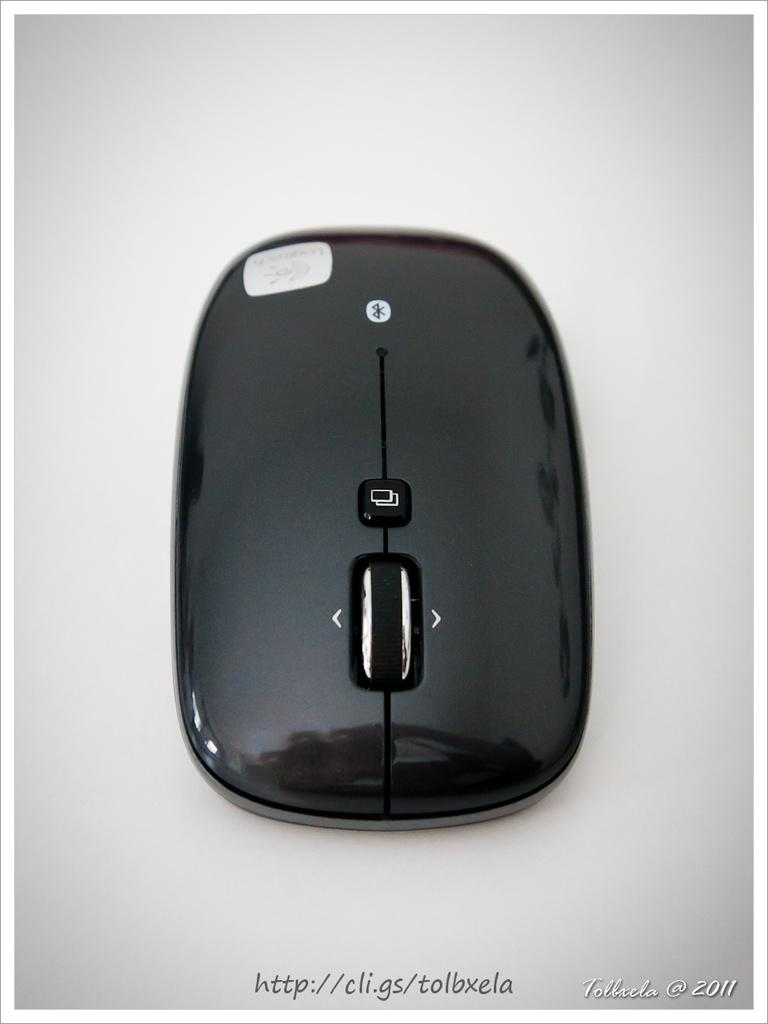<image>
Render a clear and concise summary of the photo. A cordless bluetooth mouse made by the company Logitech. 